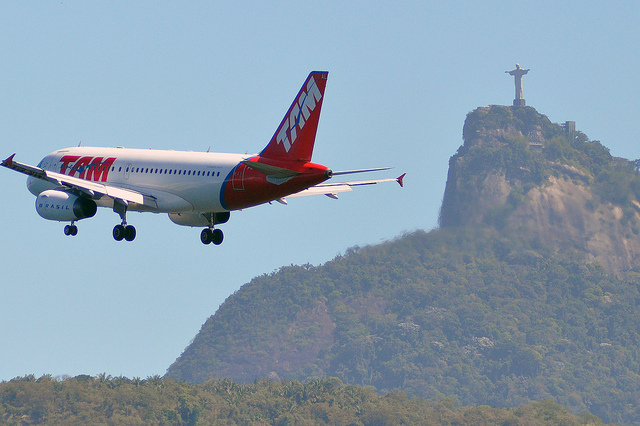Based on the content of the image, what might be the purpose of the airplane in the image? The airplane appears to be either in the process of landing or taking off, considering its low altitude and extended landing gear. Given the proximity to the Christ the Redeemer statue, the airplane is likely near Rio de Janeiro's airport. The photograph captures the aircraft's flight path with the iconic statue in the background, highlighting the scenic beauty and significant landmarks of the location. 